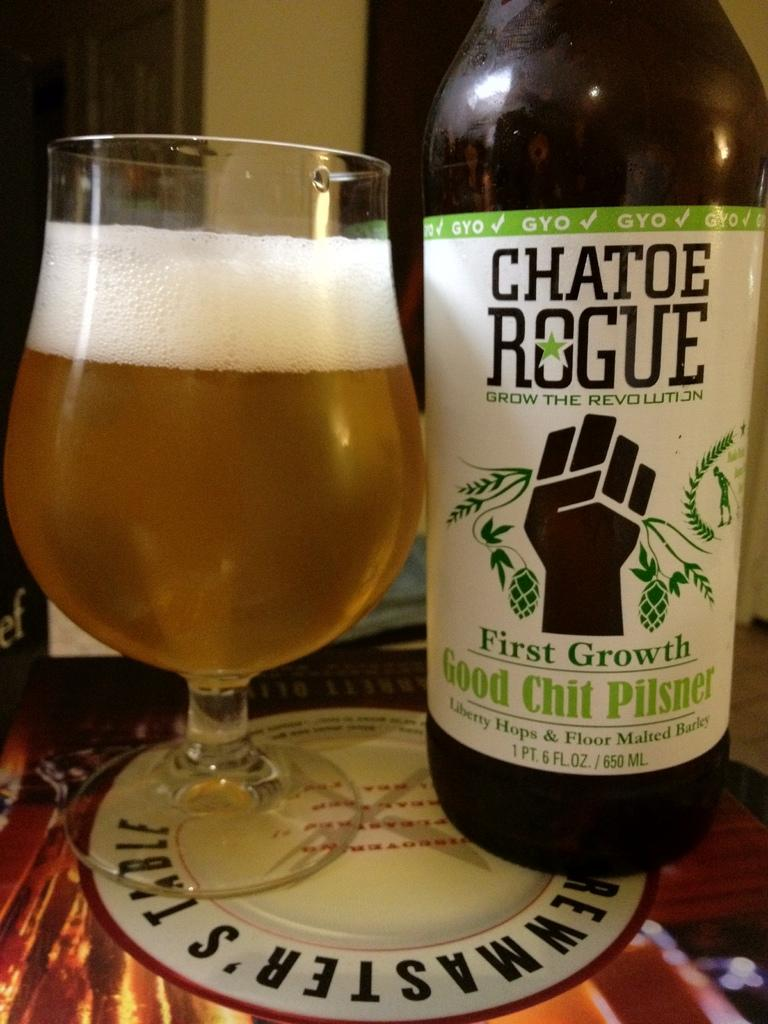Provide a one-sentence caption for the provided image. Chatoe Rogue is a maker of a good pilsner beer. 